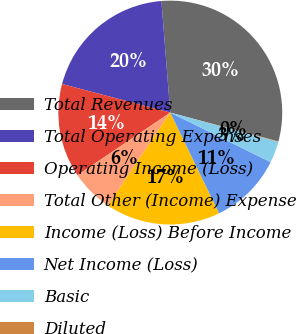Convert chart to OTSL. <chart><loc_0><loc_0><loc_500><loc_500><pie_chart><fcel>Total Revenues<fcel>Total Operating Expenses<fcel>Operating Income (Loss)<fcel>Total Other (Income) Expense<fcel>Income (Loss) Before Income<fcel>Net Income (Loss)<fcel>Basic<fcel>Diluted<nl><fcel>30.41%<fcel>19.63%<fcel>13.56%<fcel>6.13%<fcel>16.59%<fcel>10.52%<fcel>3.09%<fcel>0.06%<nl></chart> 